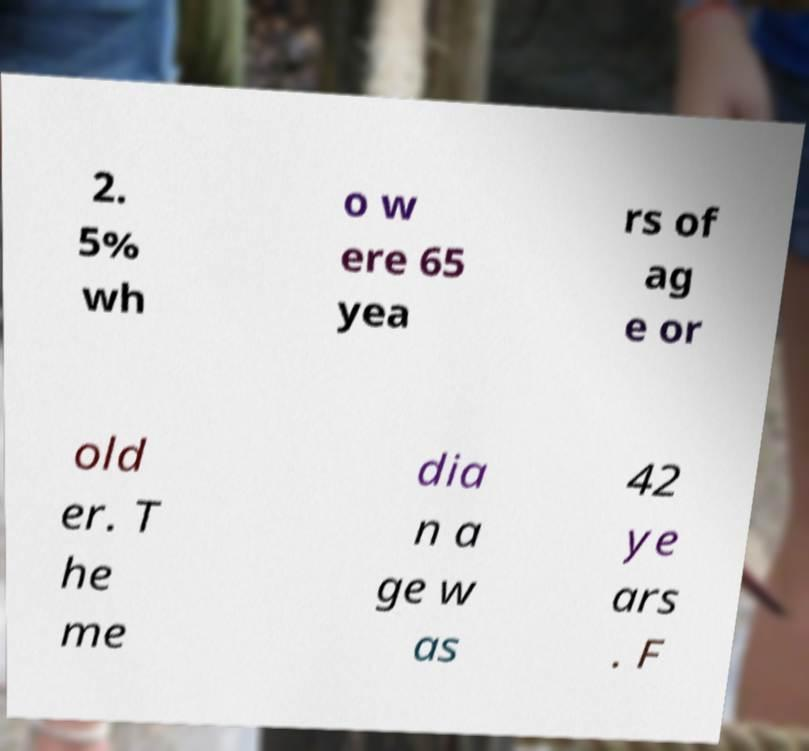Please read and relay the text visible in this image. What does it say? 2. 5% wh o w ere 65 yea rs of ag e or old er. T he me dia n a ge w as 42 ye ars . F 